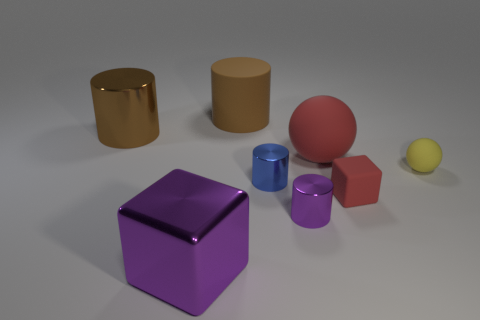Does the brown rubber thing have the same size as the yellow rubber object?
Your response must be concise. No. What size is the purple object that is behind the big metallic object that is in front of the large red matte sphere?
Your answer should be very brief. Small. There is a small object that is the same color as the large cube; what shape is it?
Make the answer very short. Cylinder. How many spheres are big red shiny objects or tiny yellow objects?
Ensure brevity in your answer.  1. There is a purple shiny cylinder; does it have the same size as the red matte object that is to the right of the large red object?
Your answer should be very brief. Yes. Is the number of large things that are in front of the tiny rubber ball greater than the number of big yellow cubes?
Ensure brevity in your answer.  Yes. What size is the purple cylinder that is the same material as the purple block?
Provide a short and direct response. Small. Is there a metal cylinder that has the same color as the big rubber cylinder?
Make the answer very short. Yes. What number of objects are small green matte things or large brown cylinders on the left side of the big purple thing?
Provide a succinct answer. 1. Is the number of small purple cylinders greater than the number of tiny purple balls?
Ensure brevity in your answer.  Yes. 